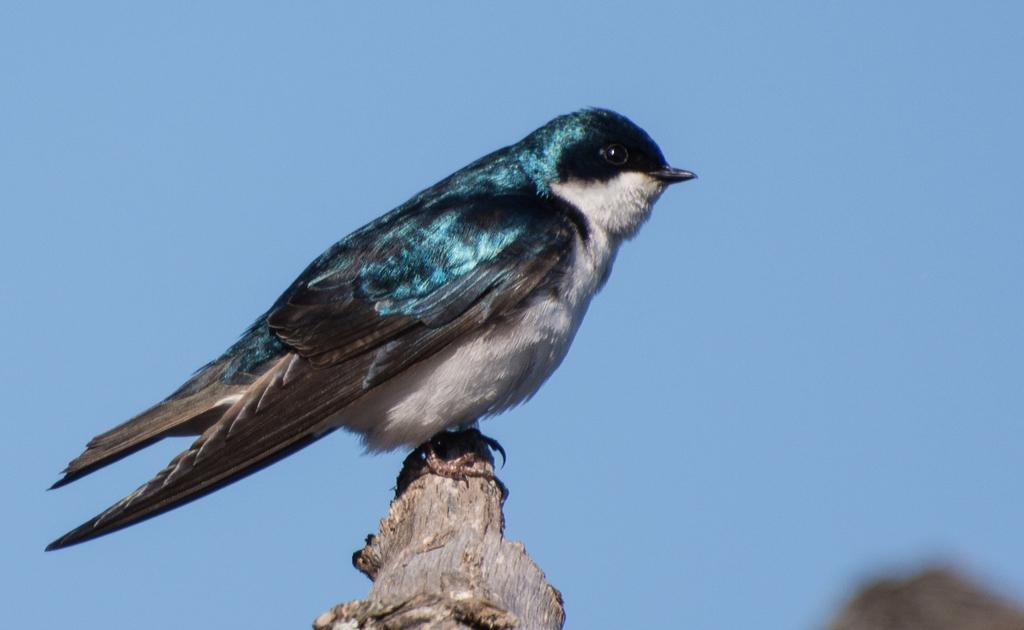What type of bird is in the picture? There is an eastern king bird in the picture. What is the bird standing on? The bird is standing on wood. What can be seen in the background of the image? There is a sky visible in the image. Is there any indication of a landscape feature in the image? There might be a mountain in the bottom right corner of the image. What type of chain is hanging from the bird's beak? There is no chain present in the image; the bird is standing on wood and there is a sky visible in the background. 